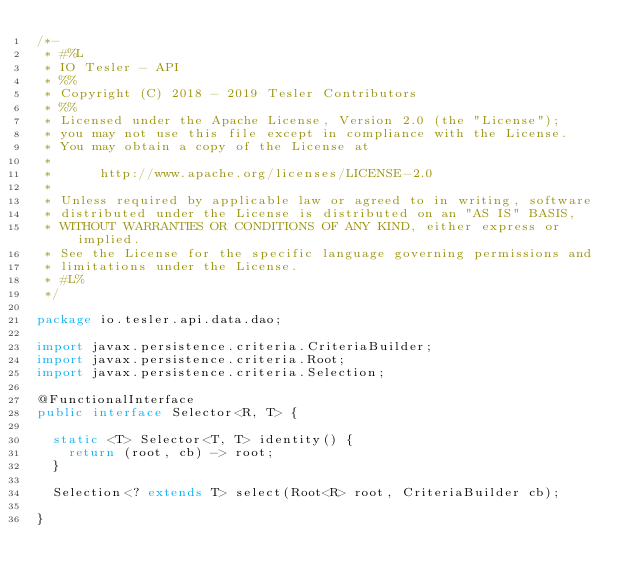<code> <loc_0><loc_0><loc_500><loc_500><_Java_>/*-
 * #%L
 * IO Tesler - API
 * %%
 * Copyright (C) 2018 - 2019 Tesler Contributors
 * %%
 * Licensed under the Apache License, Version 2.0 (the "License");
 * you may not use this file except in compliance with the License.
 * You may obtain a copy of the License at
 *
 *      http://www.apache.org/licenses/LICENSE-2.0
 *
 * Unless required by applicable law or agreed to in writing, software
 * distributed under the License is distributed on an "AS IS" BASIS,
 * WITHOUT WARRANTIES OR CONDITIONS OF ANY KIND, either express or implied.
 * See the License for the specific language governing permissions and
 * limitations under the License.
 * #L%
 */

package io.tesler.api.data.dao;

import javax.persistence.criteria.CriteriaBuilder;
import javax.persistence.criteria.Root;
import javax.persistence.criteria.Selection;

@FunctionalInterface
public interface Selector<R, T> {

	static <T> Selector<T, T> identity() {
		return (root, cb) -> root;
	}

	Selection<? extends T> select(Root<R> root, CriteriaBuilder cb);

}
</code> 